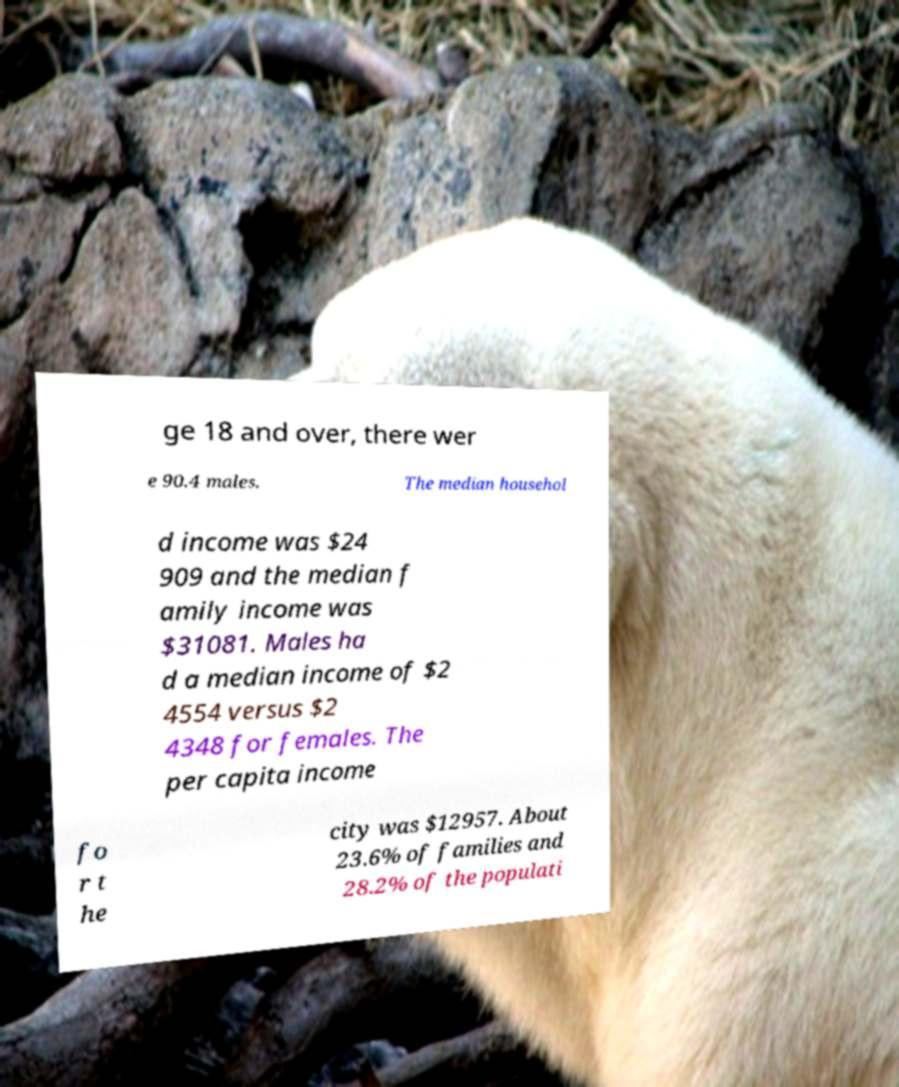Could you assist in decoding the text presented in this image and type it out clearly? ge 18 and over, there wer e 90.4 males. The median househol d income was $24 909 and the median f amily income was $31081. Males ha d a median income of $2 4554 versus $2 4348 for females. The per capita income fo r t he city was $12957. About 23.6% of families and 28.2% of the populati 